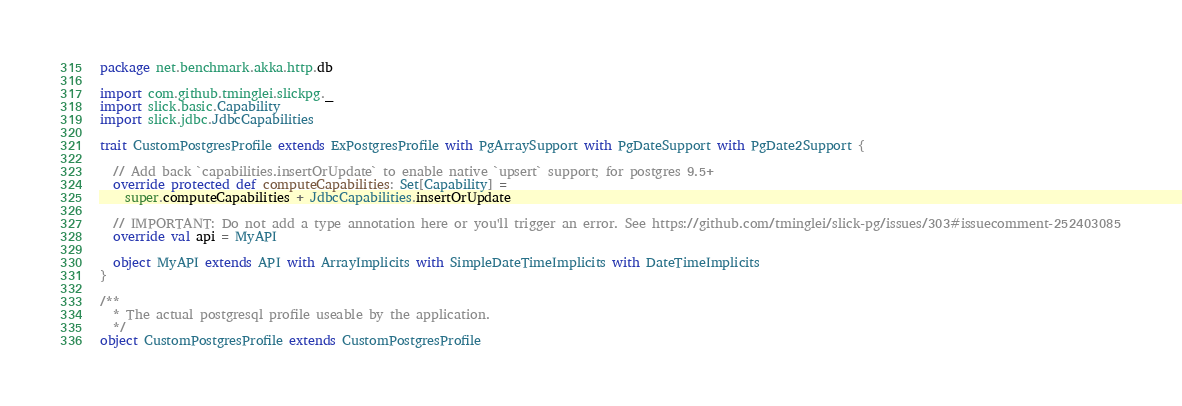Convert code to text. <code><loc_0><loc_0><loc_500><loc_500><_Scala_>package net.benchmark.akka.http.db

import com.github.tminglei.slickpg._
import slick.basic.Capability
import slick.jdbc.JdbcCapabilities

trait CustomPostgresProfile extends ExPostgresProfile with PgArraySupport with PgDateSupport with PgDate2Support {

  // Add back `capabilities.insertOrUpdate` to enable native `upsert` support; for postgres 9.5+
  override protected def computeCapabilities: Set[Capability] =
    super.computeCapabilities + JdbcCapabilities.insertOrUpdate

  // IMPORTANT: Do not add a type annotation here or you'll trigger an error. See https://github.com/tminglei/slick-pg/issues/303#issuecomment-252403085
  override val api = MyAPI

  object MyAPI extends API with ArrayImplicits with SimpleDateTimeImplicits with DateTimeImplicits
}

/**
  * The actual postgresql profile useable by the application.
  */
object CustomPostgresProfile extends CustomPostgresProfile
</code> 